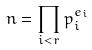Convert formula to latex. <formula><loc_0><loc_0><loc_500><loc_500>n = \prod _ { i < r } p _ { i } ^ { e _ { i } }</formula> 